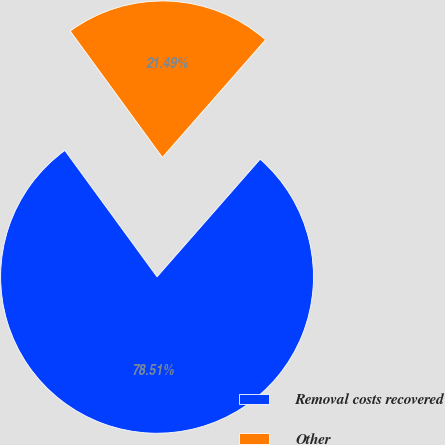<chart> <loc_0><loc_0><loc_500><loc_500><pie_chart><fcel>Removal costs recovered<fcel>Other<nl><fcel>78.51%<fcel>21.49%<nl></chart> 